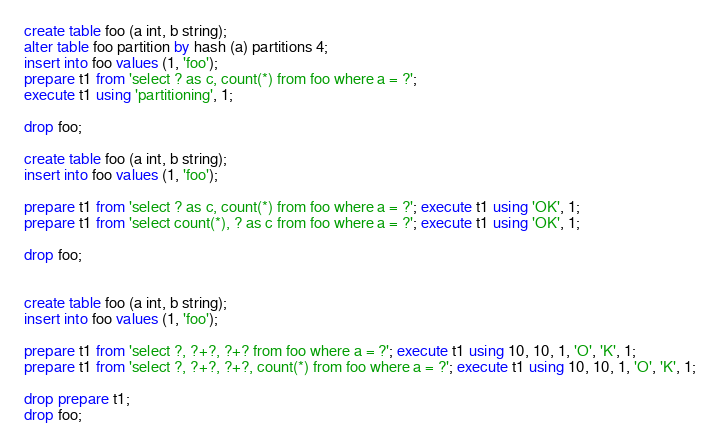<code> <loc_0><loc_0><loc_500><loc_500><_SQL_>create table foo (a int, b string);
alter table foo partition by hash (a) partitions 4;
insert into foo values (1, 'foo');
prepare t1 from 'select ? as c, count(*) from foo where a = ?';
execute t1 using 'partitioning', 1;

drop foo;

create table foo (a int, b string);
insert into foo values (1, 'foo');

prepare t1 from 'select ? as c, count(*) from foo where a = ?'; execute t1 using 'OK', 1;
prepare t1 from 'select count(*), ? as c from foo where a = ?'; execute t1 using 'OK', 1;

drop foo;


create table foo (a int, b string);
insert into foo values (1, 'foo');

prepare t1 from 'select ?, ?+?, ?+? from foo where a = ?'; execute t1 using 10, 10, 1, 'O', 'K', 1;
prepare t1 from 'select ?, ?+?, ?+?, count(*) from foo where a = ?'; execute t1 using 10, 10, 1, 'O', 'K', 1;

drop prepare t1;
drop foo;
</code> 